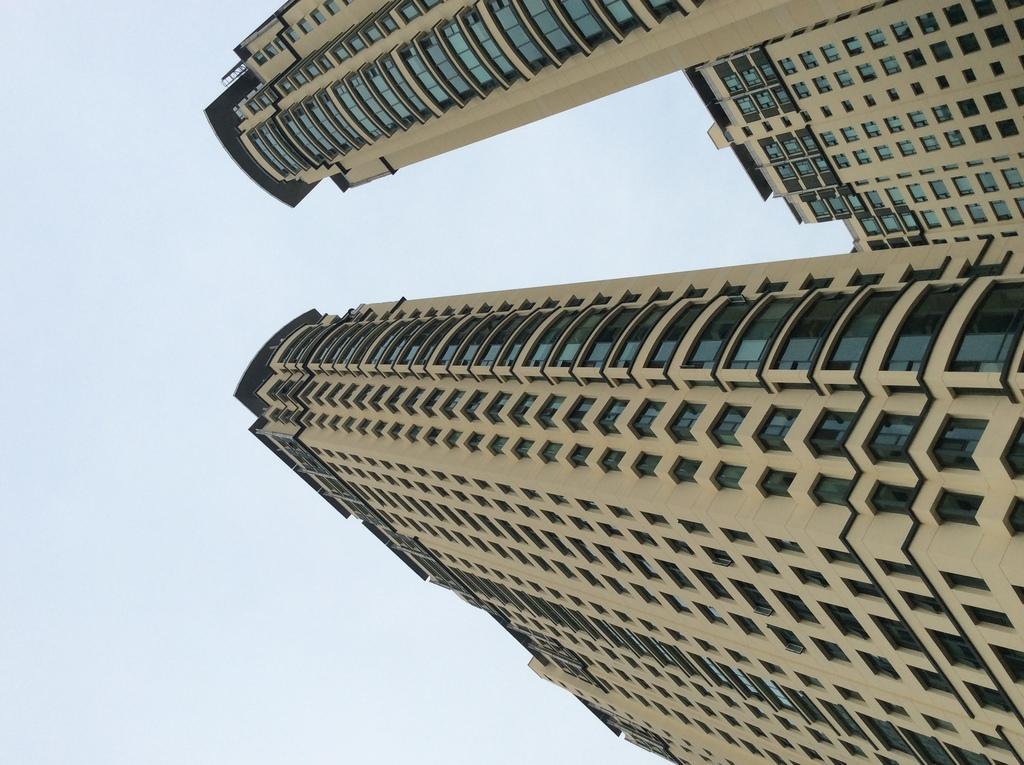How would you summarize this image in a sentence or two? On the right side, there are buildings which are having glass windows. In the background, there are clouds in the sky. 